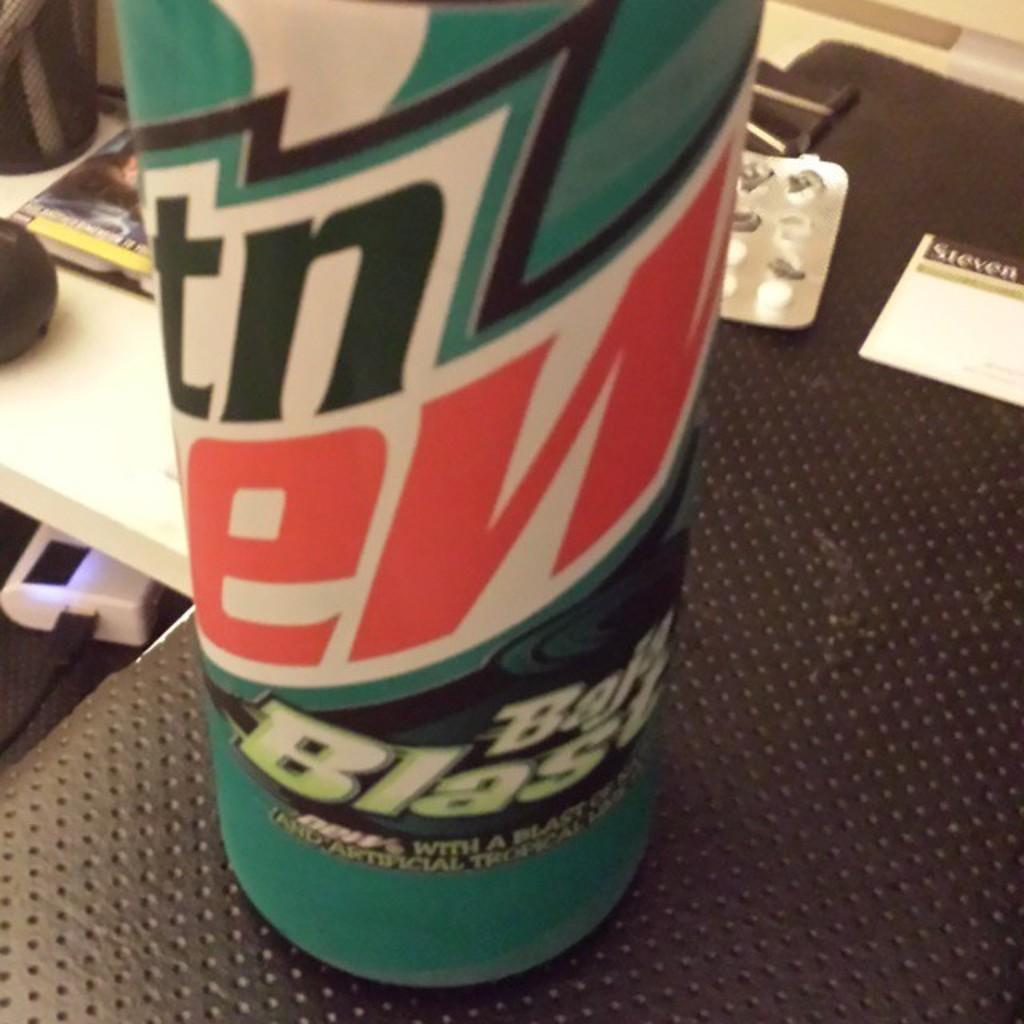<image>
Summarize the visual content of the image. A can of mountain dew on top of a brown table with a business card next to it. 